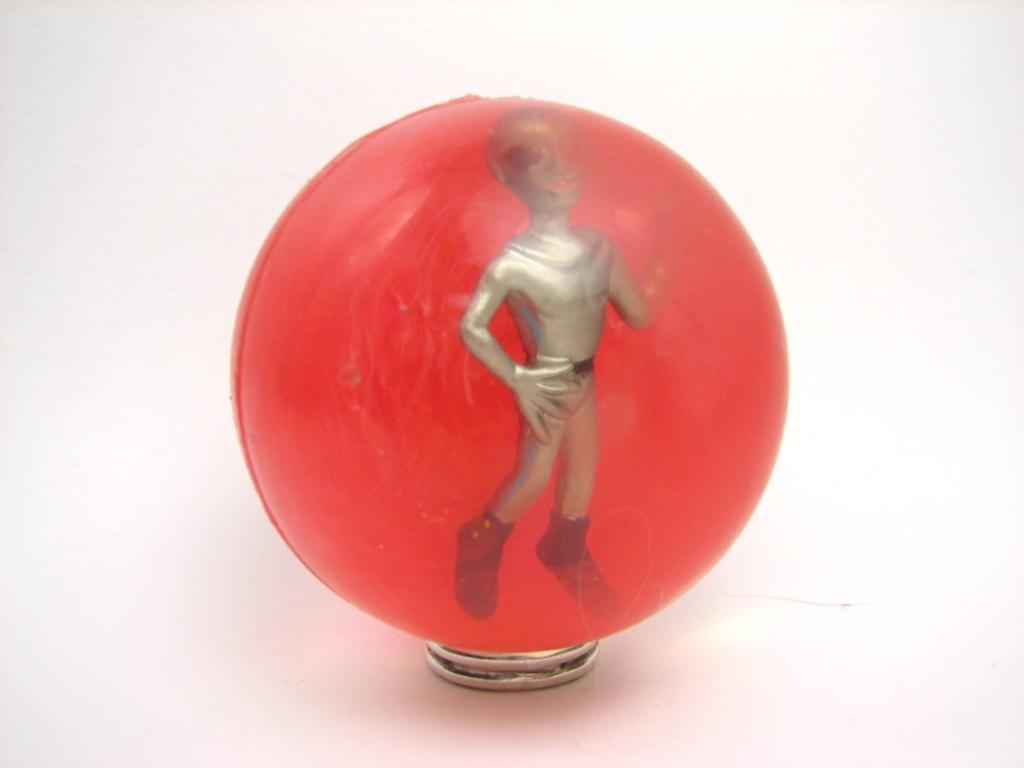How would you summarize this image in a sentence or two? In this picture, we can see a sphere with some objects. 